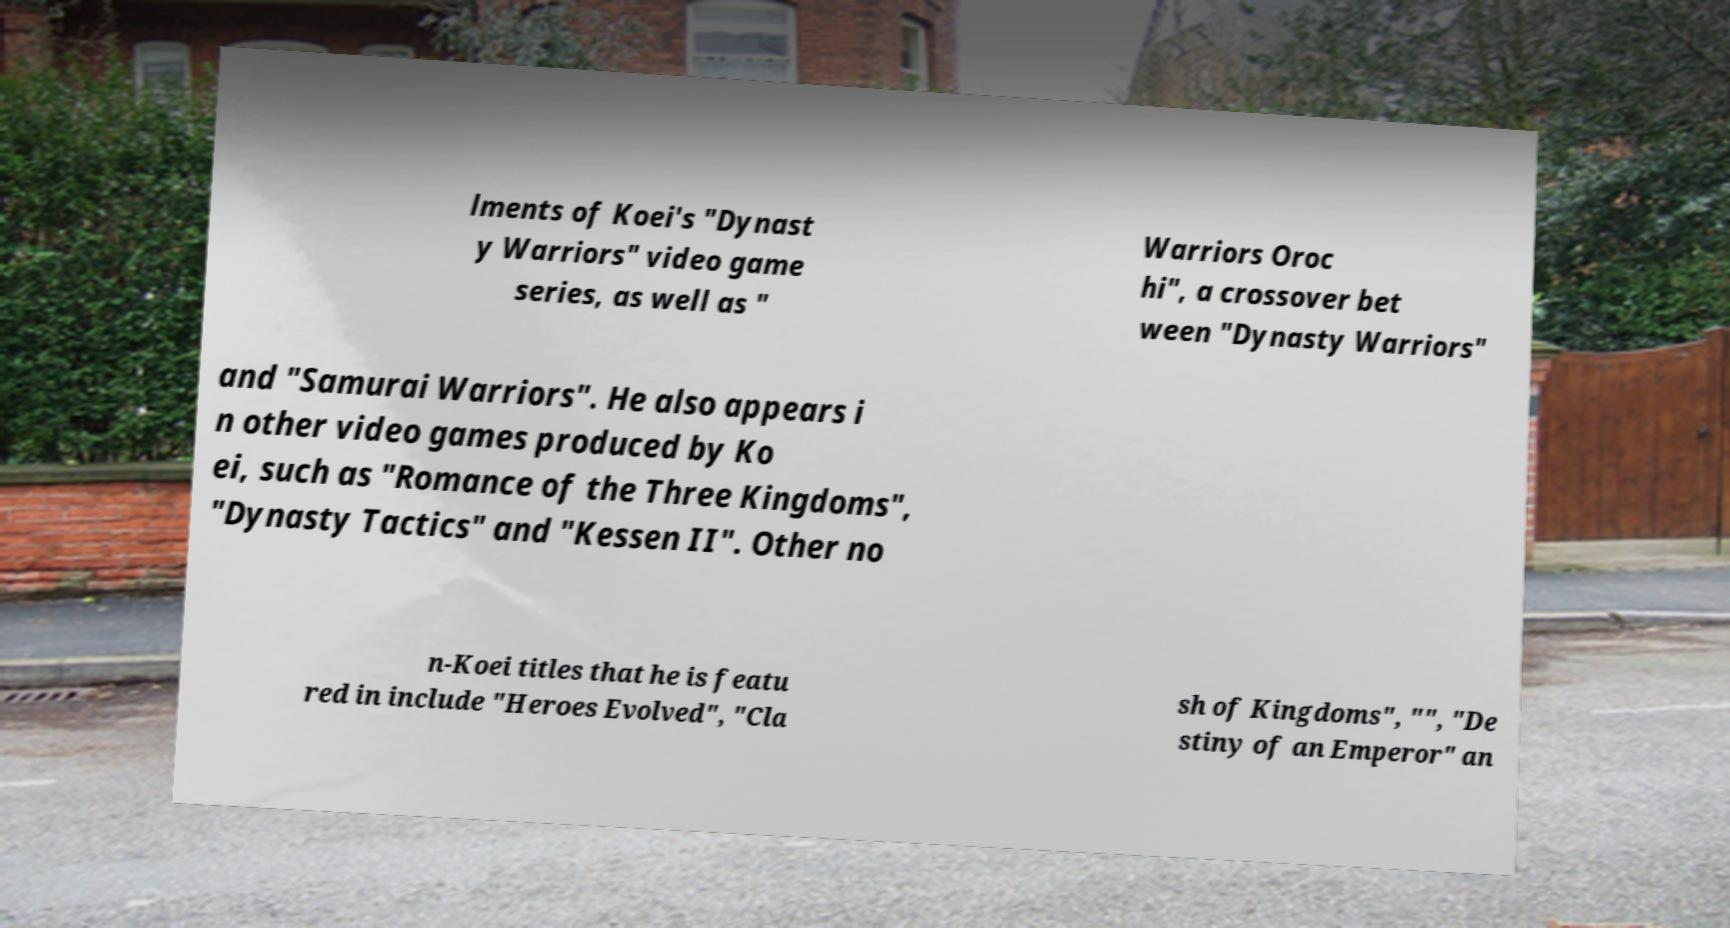Could you extract and type out the text from this image? lments of Koei's "Dynast y Warriors" video game series, as well as " Warriors Oroc hi", a crossover bet ween "Dynasty Warriors" and "Samurai Warriors". He also appears i n other video games produced by Ko ei, such as "Romance of the Three Kingdoms", "Dynasty Tactics" and "Kessen II". Other no n-Koei titles that he is featu red in include "Heroes Evolved", "Cla sh of Kingdoms", "", "De stiny of an Emperor" an 